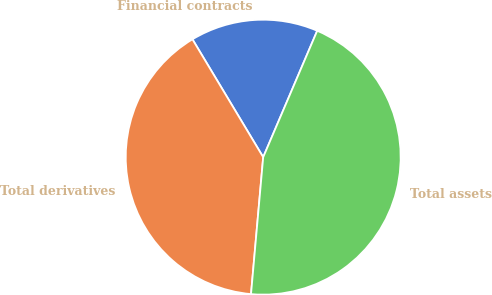<chart> <loc_0><loc_0><loc_500><loc_500><pie_chart><fcel>Financial contracts<fcel>Total derivatives<fcel>Total assets<nl><fcel>15.03%<fcel>39.98%<fcel>44.98%<nl></chart> 